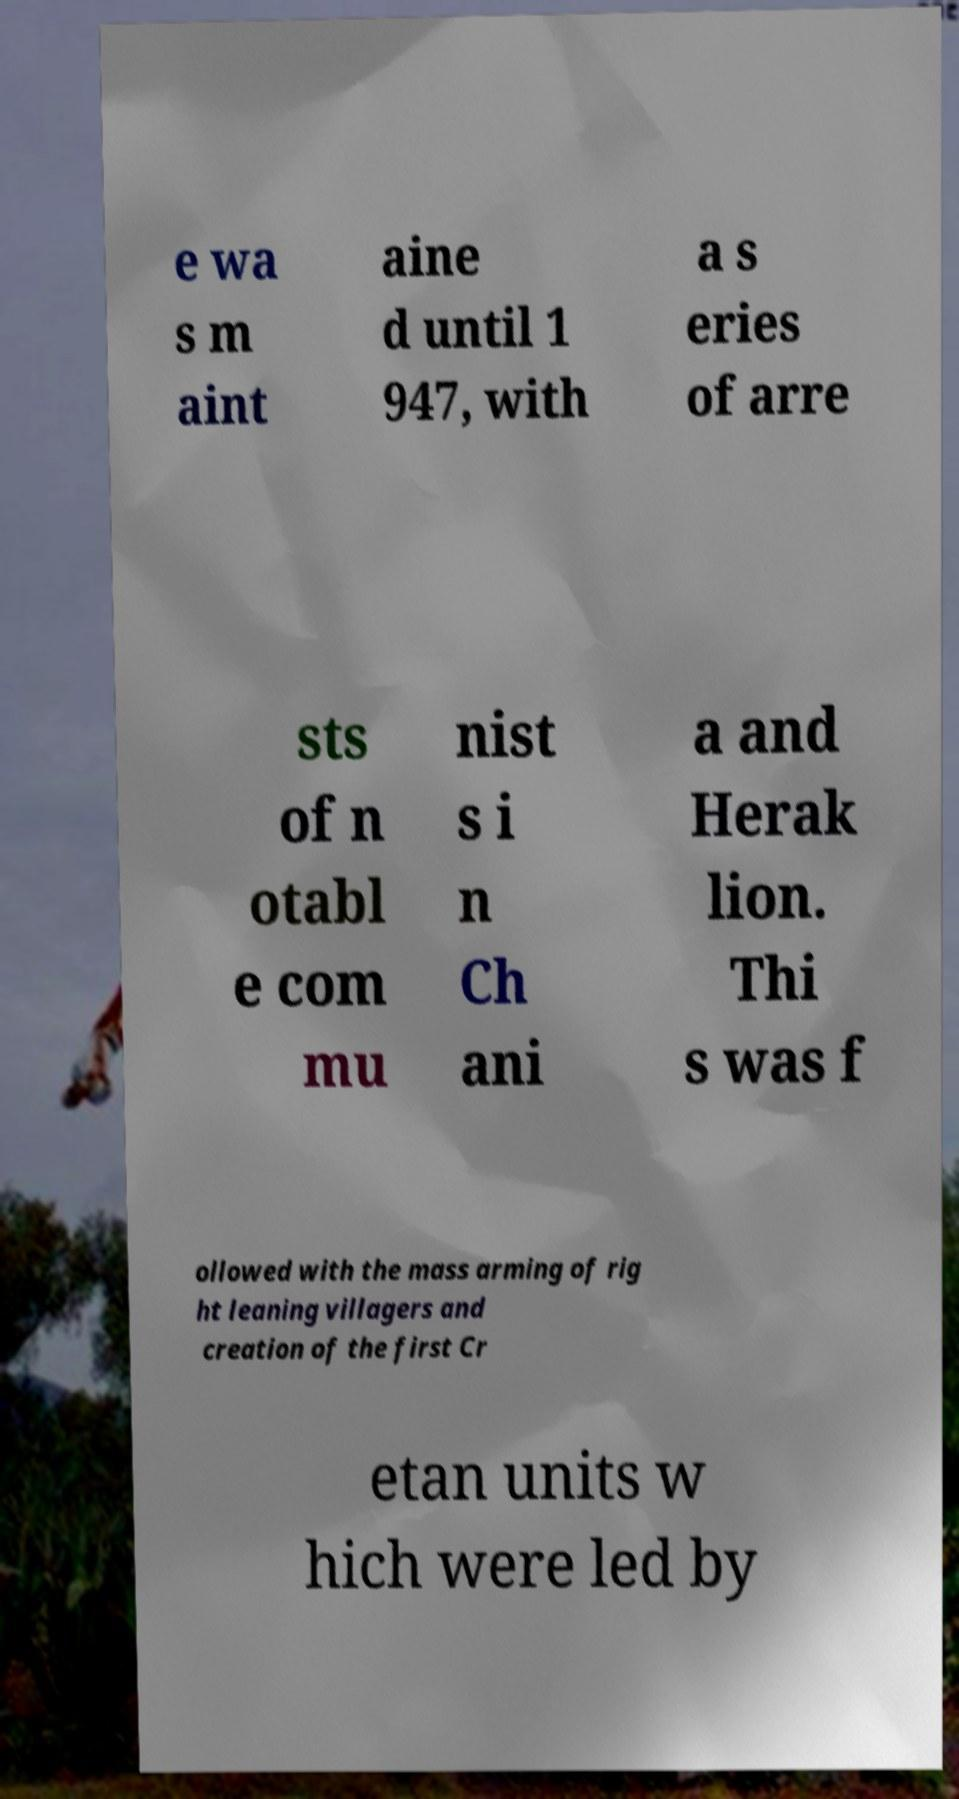Please identify and transcribe the text found in this image. e wa s m aint aine d until 1 947, with a s eries of arre sts of n otabl e com mu nist s i n Ch ani a and Herak lion. Thi s was f ollowed with the mass arming of rig ht leaning villagers and creation of the first Cr etan units w hich were led by 